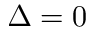Convert formula to latex. <formula><loc_0><loc_0><loc_500><loc_500>\Delta = 0</formula> 